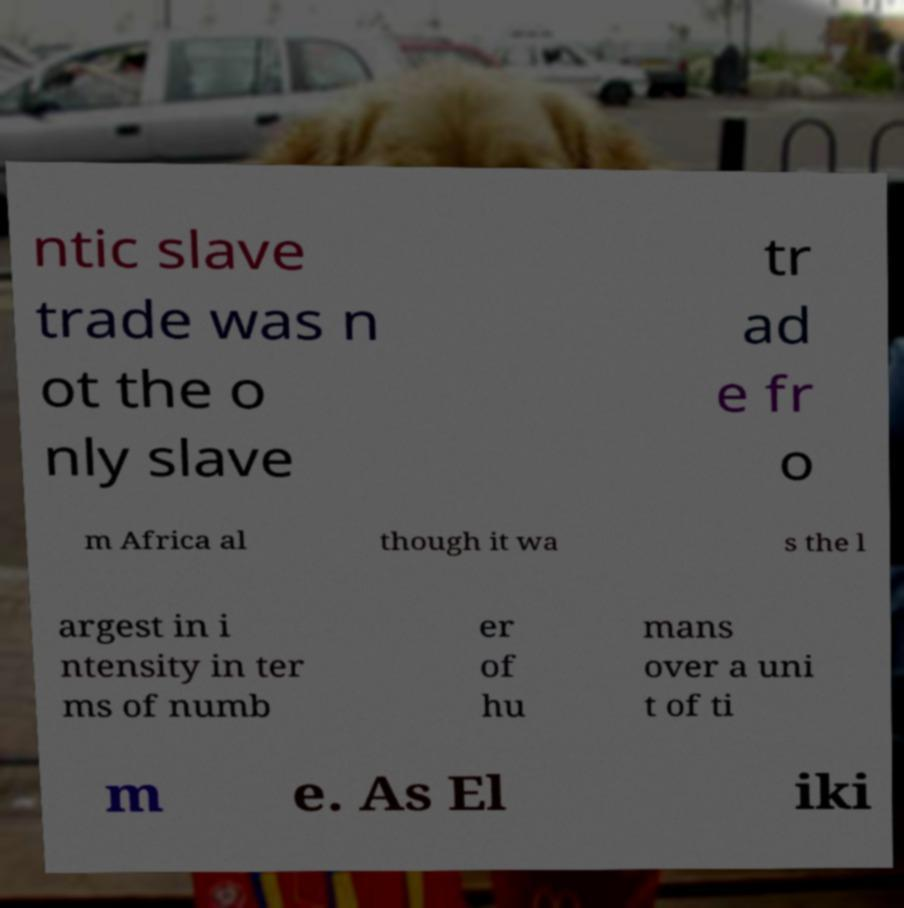I need the written content from this picture converted into text. Can you do that? ntic slave trade was n ot the o nly slave tr ad e fr o m Africa al though it wa s the l argest in i ntensity in ter ms of numb er of hu mans over a uni t of ti m e. As El iki 